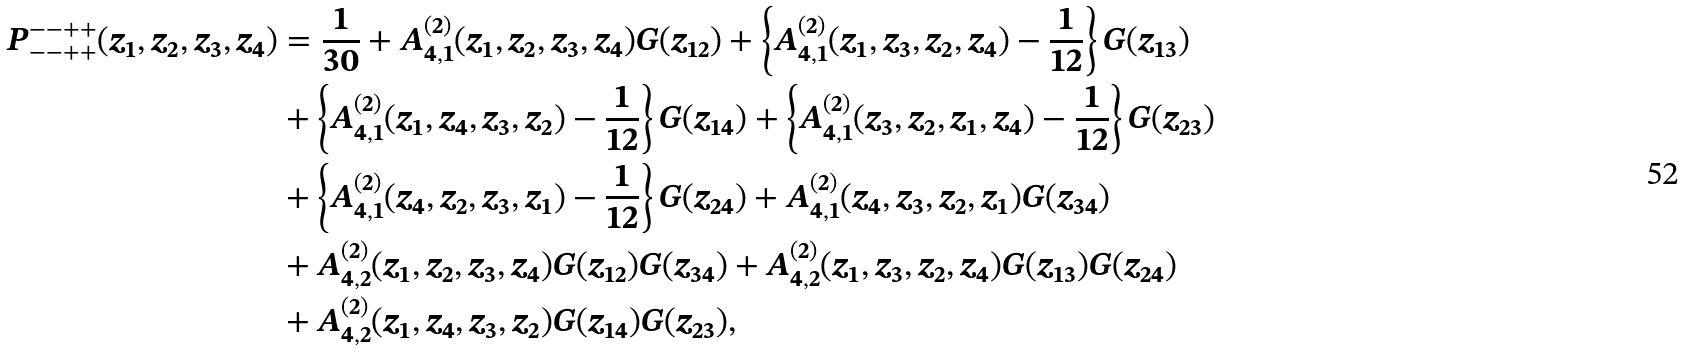Convert formula to latex. <formula><loc_0><loc_0><loc_500><loc_500>P _ { - - + + } ^ { - - + + } ( z _ { 1 } , z _ { 2 } , z _ { 3 } , z _ { 4 } ) & = \frac { 1 } { 3 0 } + A _ { 4 , 1 } ^ { ( 2 ) } ( z _ { 1 } , z _ { 2 } , z _ { 3 } , z _ { 4 } ) G ( z _ { 1 2 } ) + \left \{ A _ { 4 , 1 } ^ { ( 2 ) } ( z _ { 1 } , z _ { 3 } , z _ { 2 } , z _ { 4 } ) - \frac { 1 } { 1 2 } \right \} G ( z _ { 1 3 } ) \\ & + \left \{ A _ { 4 , 1 } ^ { ( 2 ) } ( z _ { 1 } , z _ { 4 } , z _ { 3 } , z _ { 2 } ) - \frac { 1 } { 1 2 } \right \} G ( z _ { 1 4 } ) + \left \{ A _ { 4 , 1 } ^ { ( 2 ) } ( z _ { 3 } , z _ { 2 } , z _ { 1 } , z _ { 4 } ) - \frac { 1 } { 1 2 } \right \} G ( z _ { 2 3 } ) \\ & + \left \{ A _ { 4 , 1 } ^ { ( 2 ) } ( z _ { 4 } , z _ { 2 } , z _ { 3 } , z _ { 1 } ) - \frac { 1 } { 1 2 } \right \} G ( z _ { 2 4 } ) + A _ { 4 , 1 } ^ { ( 2 ) } ( z _ { 4 } , z _ { 3 } , z _ { 2 } , z _ { 1 } ) G ( z _ { 3 4 } ) \\ & + A _ { 4 , 2 } ^ { ( 2 ) } ( z _ { 1 } , z _ { 2 } , z _ { 3 } , z _ { 4 } ) G ( z _ { 1 2 } ) G ( z _ { 3 4 } ) + A _ { 4 , 2 } ^ { ( 2 ) } ( z _ { 1 } , z _ { 3 } , z _ { 2 } , z _ { 4 } ) G ( z _ { 1 3 } ) G ( z _ { 2 4 } ) \\ & + A _ { 4 , 2 } ^ { ( 2 ) } ( z _ { 1 } , z _ { 4 } , z _ { 3 } , z _ { 2 } ) G ( z _ { 1 4 } ) G ( z _ { 2 3 } ) ,</formula> 